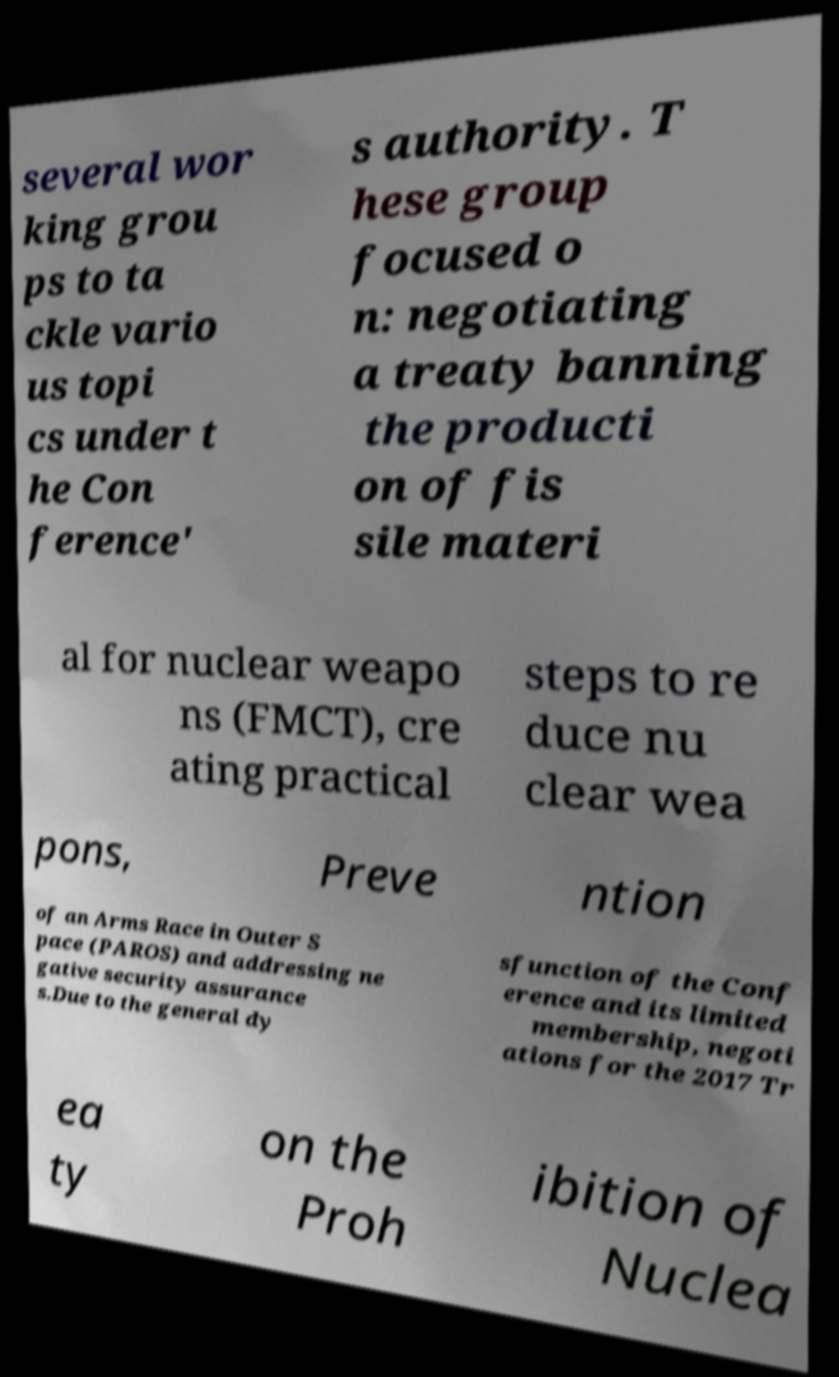Could you assist in decoding the text presented in this image and type it out clearly? several wor king grou ps to ta ckle vario us topi cs under t he Con ference' s authority. T hese group focused o n: negotiating a treaty banning the producti on of fis sile materi al for nuclear weapo ns (FMCT), cre ating practical steps to re duce nu clear wea pons, Preve ntion of an Arms Race in Outer S pace (PAROS) and addressing ne gative security assurance s.Due to the general dy sfunction of the Conf erence and its limited membership, negoti ations for the 2017 Tr ea ty on the Proh ibition of Nuclea 